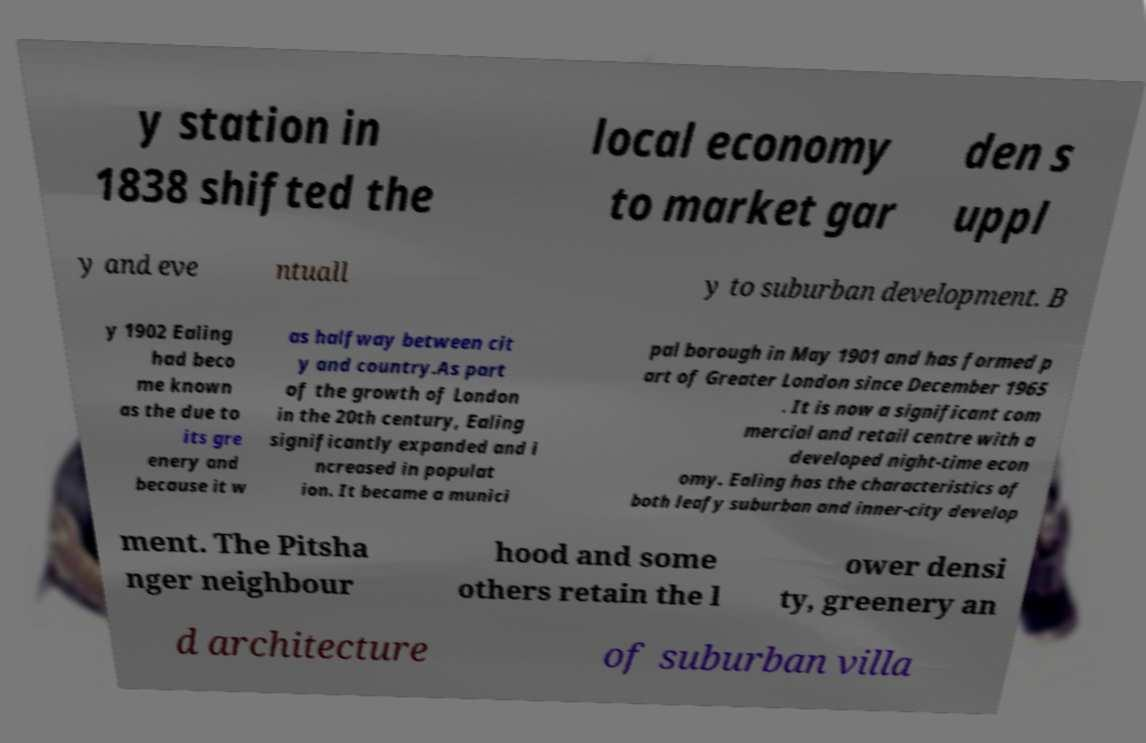I need the written content from this picture converted into text. Can you do that? y station in 1838 shifted the local economy to market gar den s uppl y and eve ntuall y to suburban development. B y 1902 Ealing had beco me known as the due to its gre enery and because it w as halfway between cit y and country.As part of the growth of London in the 20th century, Ealing significantly expanded and i ncreased in populat ion. It became a munici pal borough in May 1901 and has formed p art of Greater London since December 1965 . It is now a significant com mercial and retail centre with a developed night-time econ omy. Ealing has the characteristics of both leafy suburban and inner-city develop ment. The Pitsha nger neighbour hood and some others retain the l ower densi ty, greenery an d architecture of suburban villa 